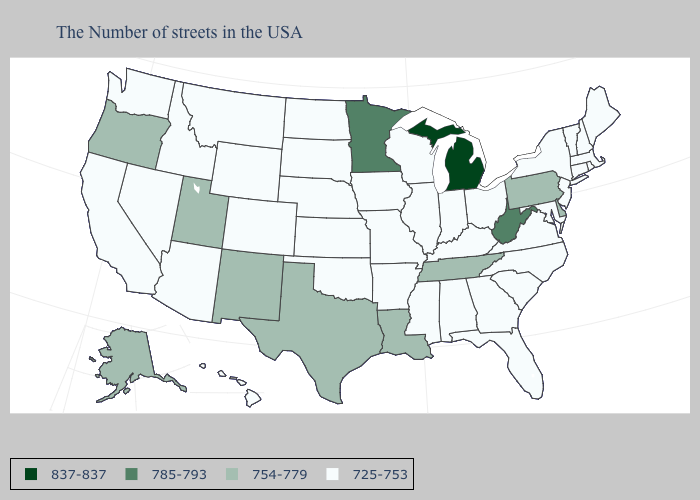What is the value of Nebraska?
Quick response, please. 725-753. Which states have the lowest value in the Northeast?
Quick response, please. Maine, Massachusetts, Rhode Island, New Hampshire, Vermont, Connecticut, New York, New Jersey. Which states have the lowest value in the Northeast?
Short answer required. Maine, Massachusetts, Rhode Island, New Hampshire, Vermont, Connecticut, New York, New Jersey. Among the states that border North Carolina , which have the lowest value?
Answer briefly. Virginia, South Carolina, Georgia. What is the highest value in the Northeast ?
Answer briefly. 754-779. What is the lowest value in states that border Utah?
Give a very brief answer. 725-753. What is the highest value in the USA?
Write a very short answer. 837-837. Does South Dakota have the same value as Ohio?
Concise answer only. Yes. What is the value of Nebraska?
Write a very short answer. 725-753. Does Virginia have the same value as Kansas?
Give a very brief answer. Yes. Name the states that have a value in the range 754-779?
Keep it brief. Delaware, Pennsylvania, Tennessee, Louisiana, Texas, New Mexico, Utah, Oregon, Alaska. Name the states that have a value in the range 754-779?
Quick response, please. Delaware, Pennsylvania, Tennessee, Louisiana, Texas, New Mexico, Utah, Oregon, Alaska. What is the value of Utah?
Quick response, please. 754-779. Does Montana have the lowest value in the West?
Give a very brief answer. Yes. What is the value of Louisiana?
Write a very short answer. 754-779. 